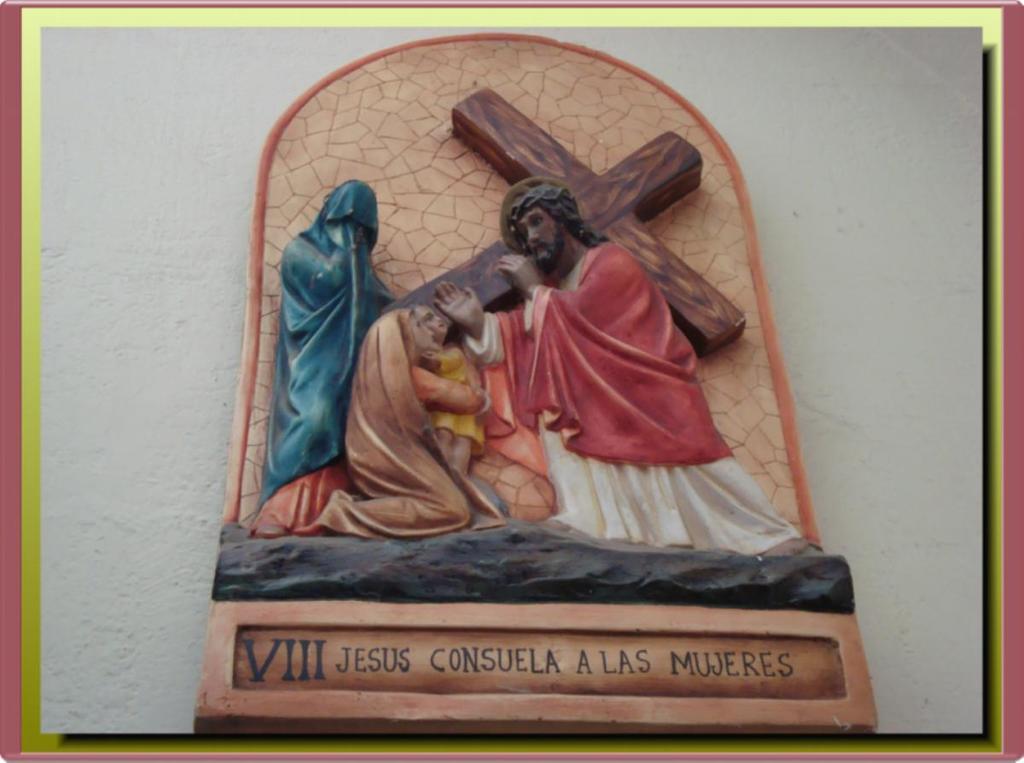Who is helping the women?
Your response must be concise. Jesus. What roman numerals are seen on this statue?
Ensure brevity in your answer.  Viii. 